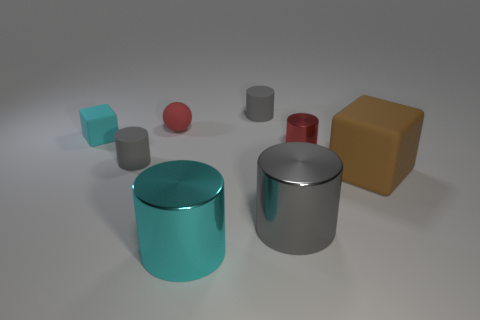Subtract all purple cubes. How many gray cylinders are left? 3 Subtract all red cylinders. How many cylinders are left? 4 Subtract all tiny red metal cylinders. How many cylinders are left? 4 Subtract all purple cylinders. Subtract all cyan blocks. How many cylinders are left? 5 Add 2 small gray matte cylinders. How many objects exist? 10 Subtract all cubes. How many objects are left? 6 Subtract all big cyan cylinders. Subtract all big cyan shiny cylinders. How many objects are left? 6 Add 2 metal cylinders. How many metal cylinders are left? 5 Add 3 red rubber spheres. How many red rubber spheres exist? 4 Subtract 0 green balls. How many objects are left? 8 